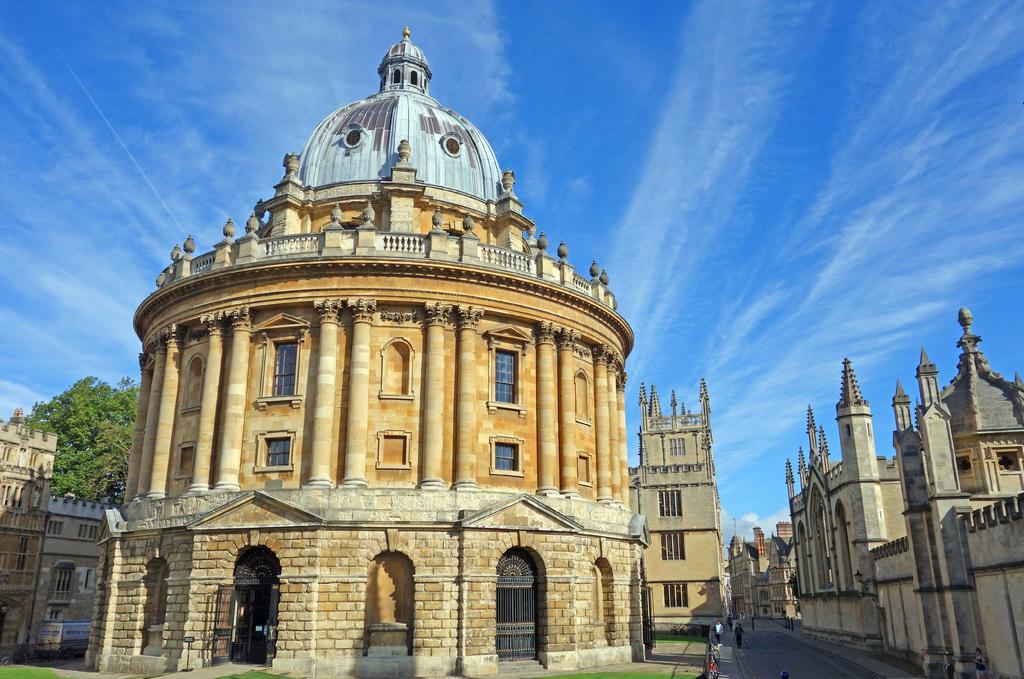Please provide a concise description of this image. In this image, we can see so many buildings, walls, windows and tree. At the bottom of the image, we can see people, grass and road. Background there is the sky. 